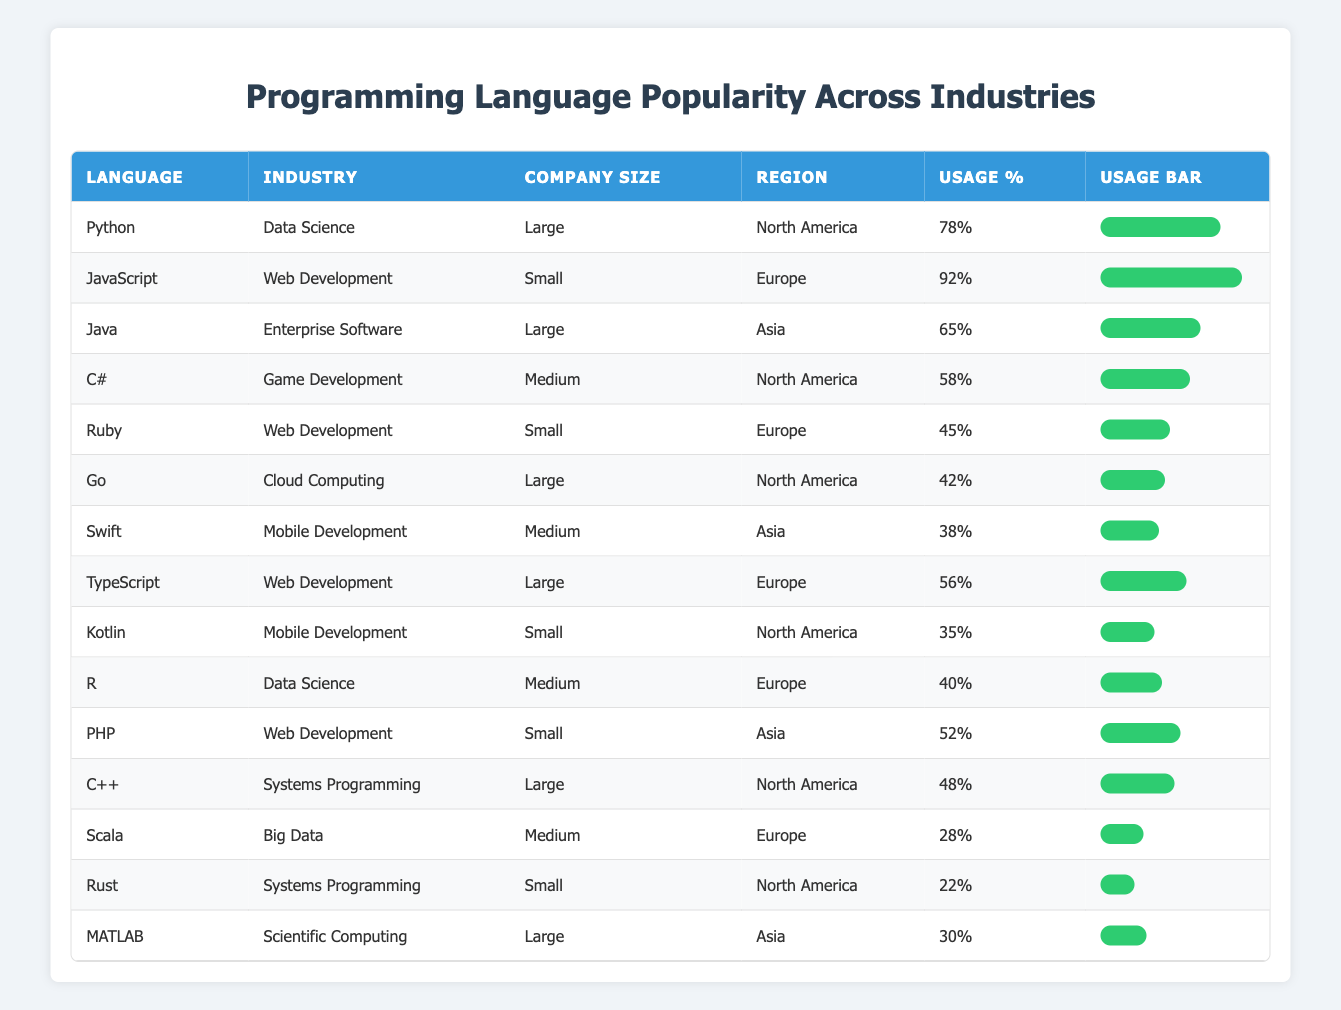What programming language has the highest usage percentage in 2023? The visibility of the usage percentages in the table shows that JavaScript has the highest usage percentage at 92%. This is directly retrieved from the table.
Answer: JavaScript Which industry uses Python the most in 2023? Python is primarily used in the Data Science industry with a usage percentage of 78%. This can be found easily in the table by looking for the row with Python.
Answer: Data Science What is the average usage percentage of programming languages in the Mobile Development industry in 2023? The languages for Mobile Development are Swift (38%) and Kotlin (35%). We sum these percentages: 38 + 35 = 73. Then, we divide by 2 to get the average: 73 / 2 = 36.5.
Answer: 36.5 Is Ruby used more than PHP in Web Development for the year 2023? In the table, Ruby has a usage percentage of 45%, while PHP has a usage percentage of 52%. Since 45% is less than 52%, we conclude that Ruby is not used more than PHP in 2023.
Answer: No Which company size has the highest usage percentage for C# in Game Development? C# is used in the Game Development industry by companies of Medium size, with a usage percentage of 58%. The row for C# can be checked in the table to confirm this.
Answer: Medium What are the total usage percentages for programming languages in the Systems Programming industry? The languages in Systems Programming are C++ (48%) and Rust (22%). To find the total, we add these values: 48 + 22 = 70. Therefore, the total usage percentage is 70%.
Answer: 70 What is the difference in usage percentage between Java and Python? From the table, Python has a usage percentage of 78% and Java has 65%. The difference is calculated as: 78 - 65 = 13.
Answer: 13 In which region is Go used most, and what is its usage percentage? According to the table, Go is used in North America with a usage percentage of 42%. This is found by checking the row for Go in the North America region.
Answer: North America, 42% Does the Data Science industry use any programming language less than 40% in 2023? In the Data Science industry, the languages listed are Python (78%) and R (40%). Since R has exactly 40%, our answer is based on no languages being less than 40%.
Answer: No 